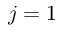Convert formula to latex. <formula><loc_0><loc_0><loc_500><loc_500>j = 1</formula> 